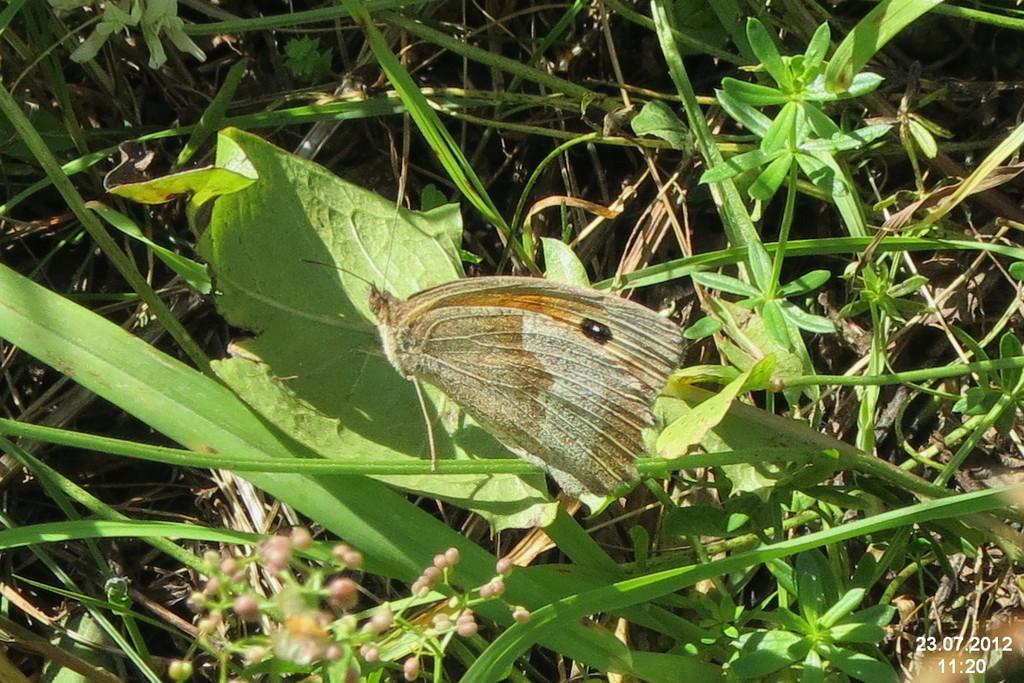Could you give a brief overview of what you see in this image? In the foreground of this picture, there is a butterfly on the leaf. In the background, we can see the grass and the pants. 